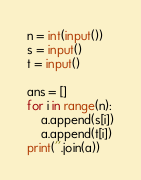Convert code to text. <code><loc_0><loc_0><loc_500><loc_500><_Python_>n = int(input())
s = input()
t = input()

ans = []
for i in range(n):
    a.append(s[i])
    a.append(t[i])
print(''.join(a))</code> 